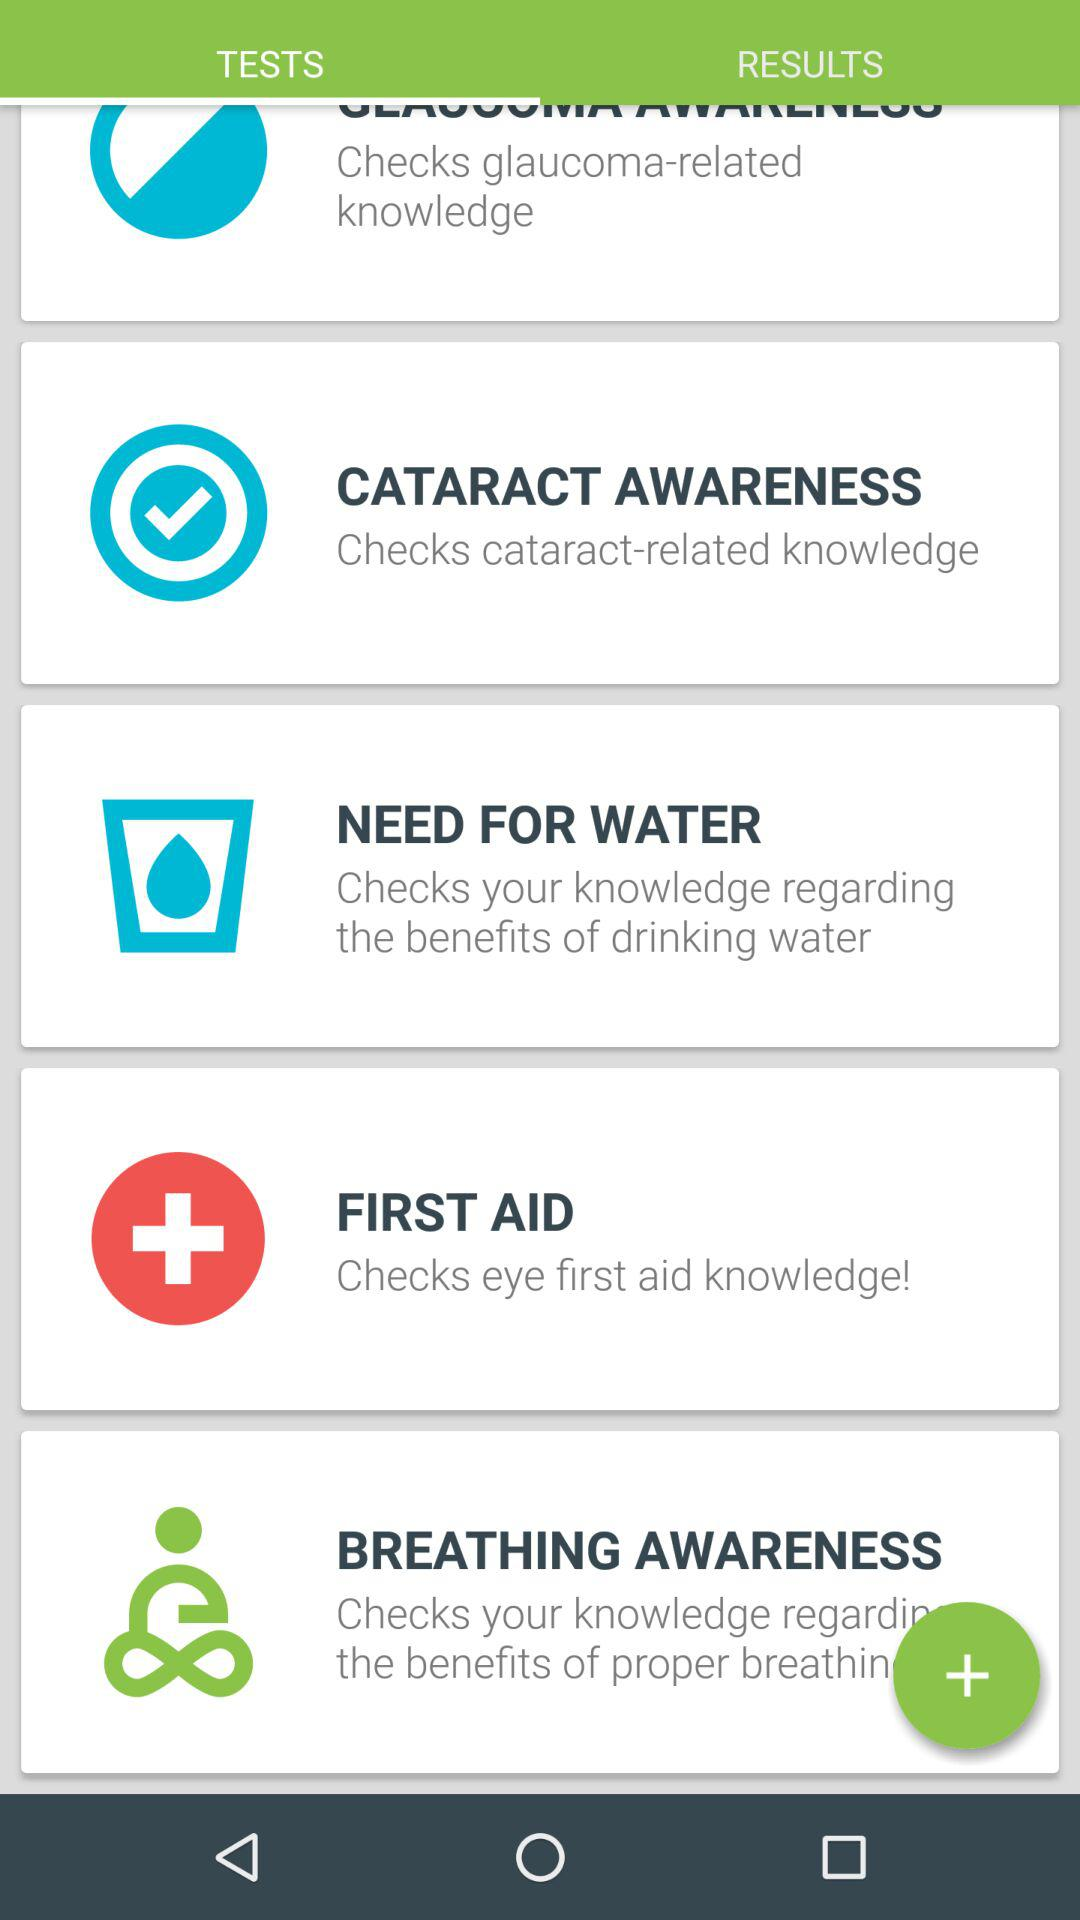Which items are available in "RESULTS"?
When the provided information is insufficient, respond with <no answer>. <no answer> 